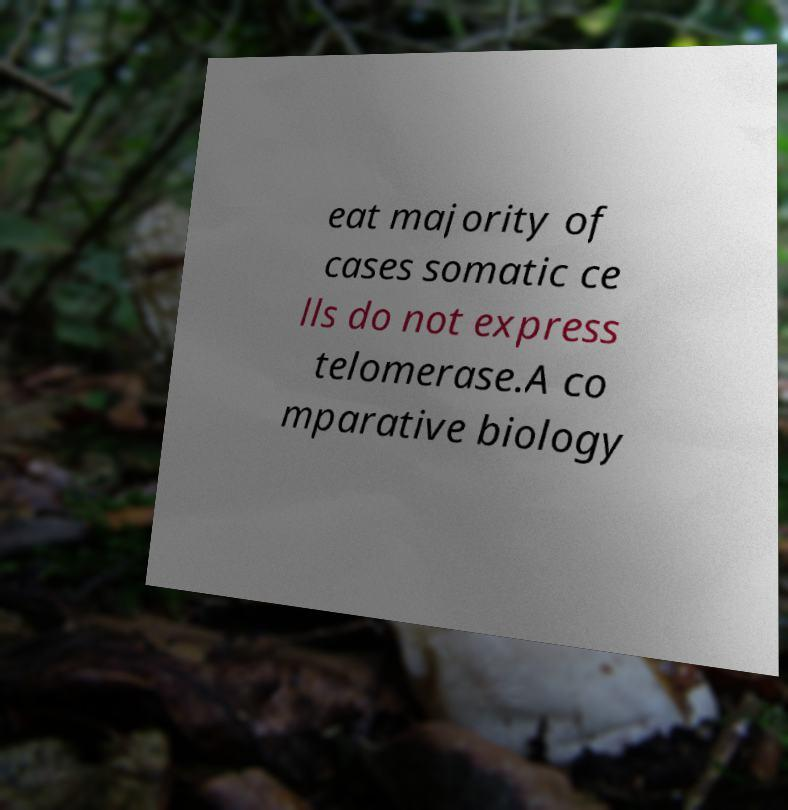Could you extract and type out the text from this image? eat majority of cases somatic ce lls do not express telomerase.A co mparative biology 